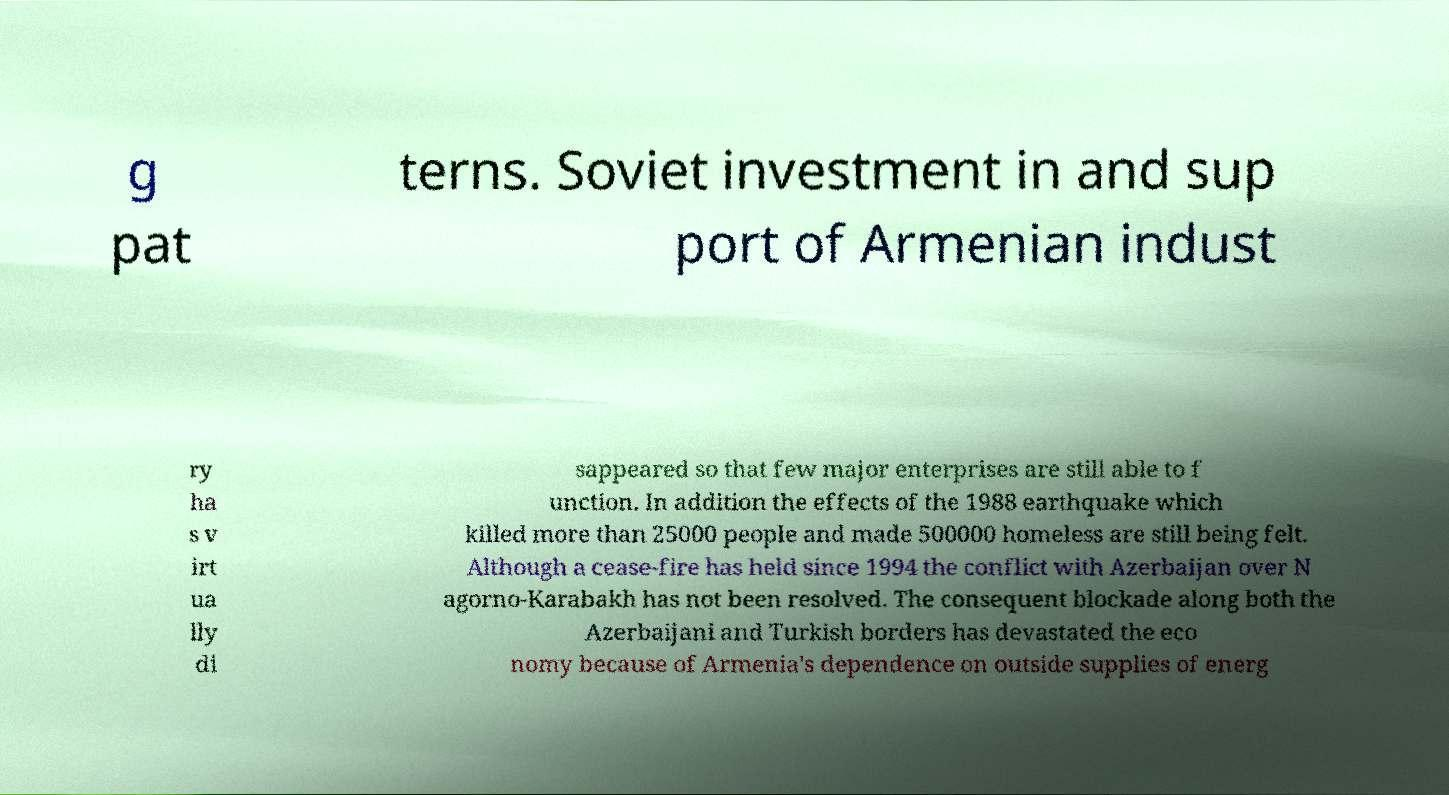Please read and relay the text visible in this image. What does it say? g pat terns. Soviet investment in and sup port of Armenian indust ry ha s v irt ua lly di sappeared so that few major enterprises are still able to f unction. In addition the effects of the 1988 earthquake which killed more than 25000 people and made 500000 homeless are still being felt. Although a cease-fire has held since 1994 the conflict with Azerbaijan over N agorno-Karabakh has not been resolved. The consequent blockade along both the Azerbaijani and Turkish borders has devastated the eco nomy because of Armenia's dependence on outside supplies of energ 